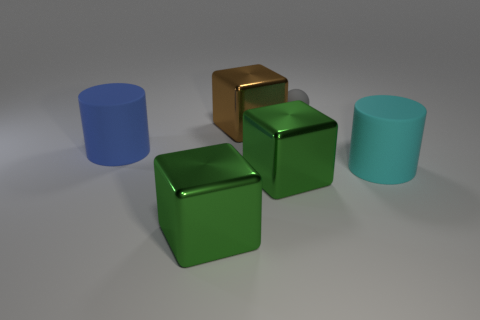The rubber object that is the same size as the cyan cylinder is what color?
Your response must be concise. Blue. What shape is the green thing that is behind the metallic thing left of the big thing that is behind the blue object?
Give a very brief answer. Cube. There is a large cyan thing in front of the big blue matte object; how many matte objects are to the left of it?
Your response must be concise. 2. Do the large metal object that is behind the cyan object and the matte object on the left side of the small matte object have the same shape?
Ensure brevity in your answer.  No. There is a cyan matte cylinder; how many cylinders are to the right of it?
Provide a succinct answer. 0. Is the material of the big green cube that is on the right side of the big brown cube the same as the large blue cylinder?
Keep it short and to the point. No. The other object that is the same shape as the large blue rubber thing is what color?
Your response must be concise. Cyan. What is the shape of the large brown shiny object?
Ensure brevity in your answer.  Cube. How many objects are big cyan rubber cylinders or green rubber things?
Your response must be concise. 1. Is the color of the large thing to the right of the gray matte thing the same as the matte thing that is to the left of the brown metal thing?
Keep it short and to the point. No. 